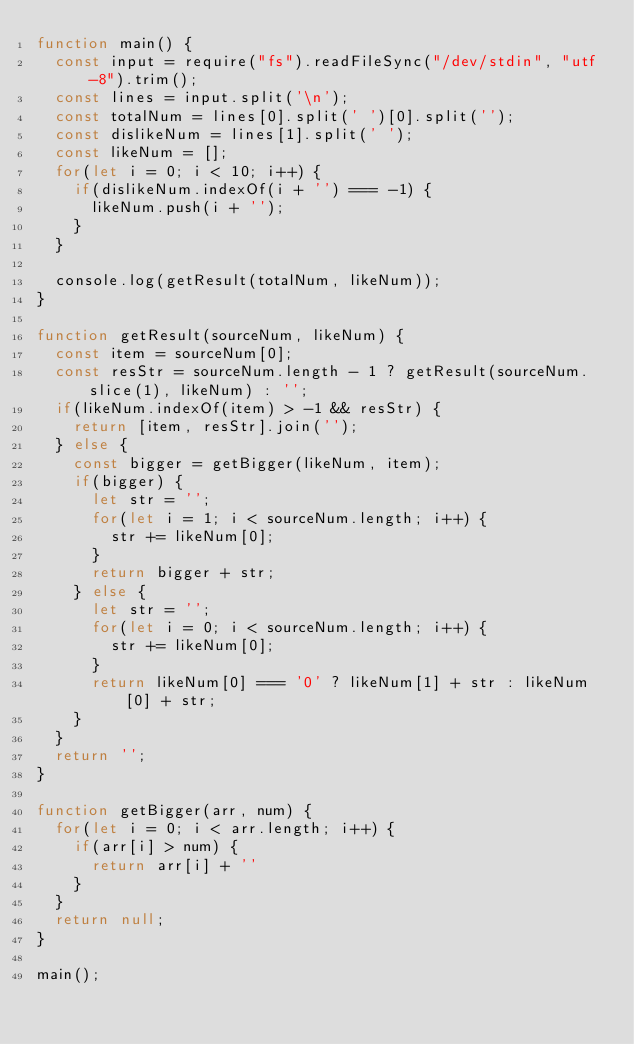<code> <loc_0><loc_0><loc_500><loc_500><_JavaScript_>function main() {
  const input = require("fs").readFileSync("/dev/stdin", "utf-8").trim();
  const lines = input.split('\n');
  const totalNum = lines[0].split(' ')[0].split('');
  const dislikeNum = lines[1].split(' ');
  const likeNum = [];
  for(let i = 0; i < 10; i++) {
    if(dislikeNum.indexOf(i + '') === -1) {
      likeNum.push(i + '');
    }
  }

  console.log(getResult(totalNum, likeNum));
}

function getResult(sourceNum, likeNum) {
  const item = sourceNum[0];
  const resStr = sourceNum.length - 1 ? getResult(sourceNum.slice(1), likeNum) : '';
  if(likeNum.indexOf(item) > -1 && resStr) {
    return [item, resStr].join('');
  } else {
    const bigger = getBigger(likeNum, item);
    if(bigger) {
      let str = '';
      for(let i = 1; i < sourceNum.length; i++) {
        str += likeNum[0];
      }
      return bigger + str;
    } else {
      let str = '';
      for(let i = 0; i < sourceNum.length; i++) {
        str += likeNum[0];
      }
      return likeNum[0] === '0' ? likeNum[1] + str : likeNum[0] + str;
    }
  }
  return '';
}

function getBigger(arr, num) {
  for(let i = 0; i < arr.length; i++) {
    if(arr[i] > num) {
      return arr[i] + ''
    }
  }
  return null;
}

main();
</code> 